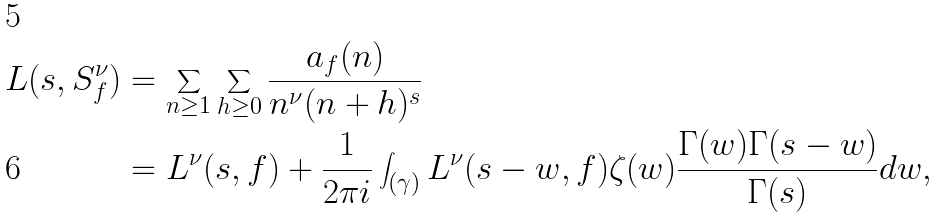<formula> <loc_0><loc_0><loc_500><loc_500>L ( s , S _ { f } ^ { \nu } ) & = \sum _ { n \geq 1 } \sum _ { h \geq 0 } \frac { a _ { f } ( n ) } { n ^ { \nu } ( n + h ) ^ { s } } \\ & = L ^ { \nu } ( s , f ) + \frac { 1 } { 2 \pi i } \int _ { ( \gamma ) } L ^ { \nu } ( s - w , f ) \zeta ( w ) \frac { \Gamma ( w ) \Gamma ( s - w ) } { \Gamma ( s ) } d w ,</formula> 